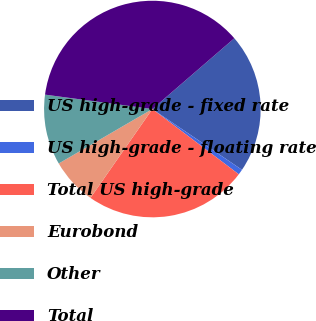Convert chart to OTSL. <chart><loc_0><loc_0><loc_500><loc_500><pie_chart><fcel>US high-grade - fixed rate<fcel>US high-grade - floating rate<fcel>Total US high-grade<fcel>Eurobond<fcel>Other<fcel>Total<nl><fcel>20.82%<fcel>0.81%<fcel>24.39%<fcel>6.93%<fcel>10.51%<fcel>36.54%<nl></chart> 